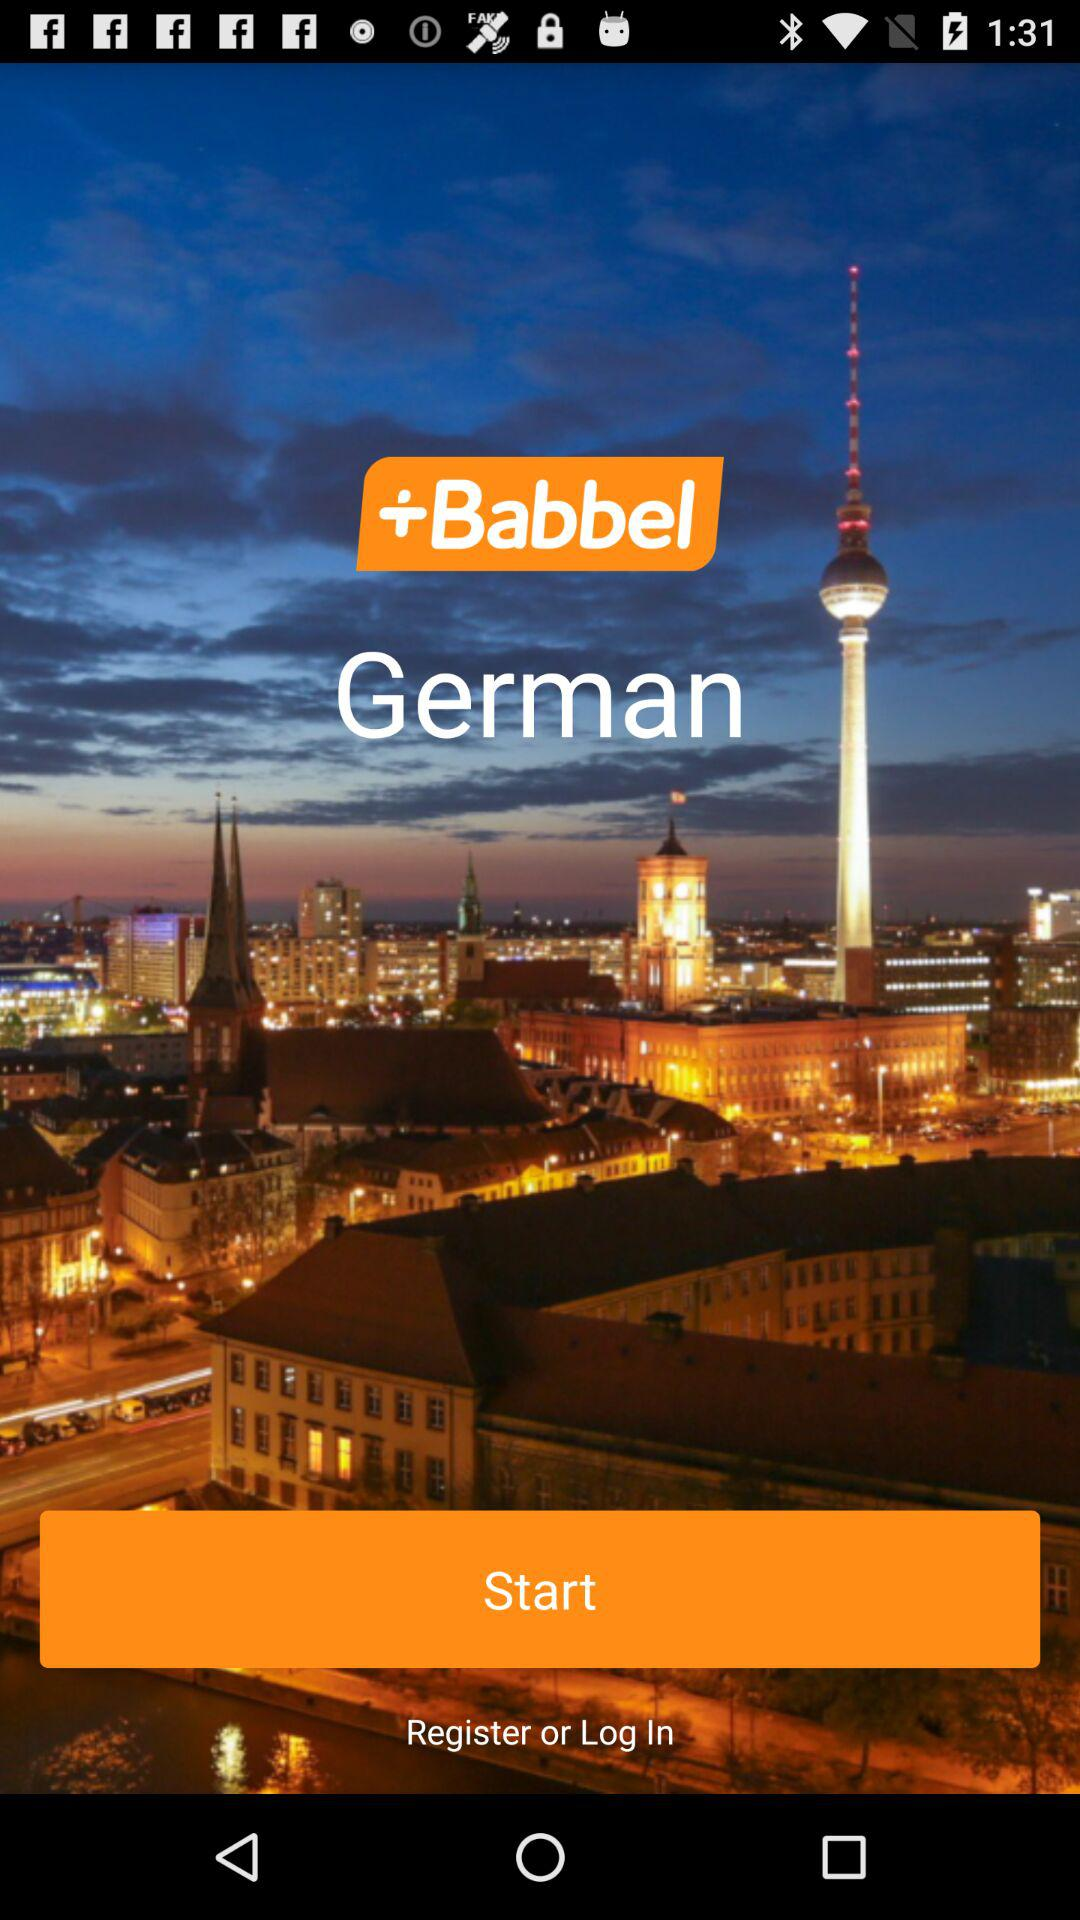What is the application name? The application name is "Babbel". 